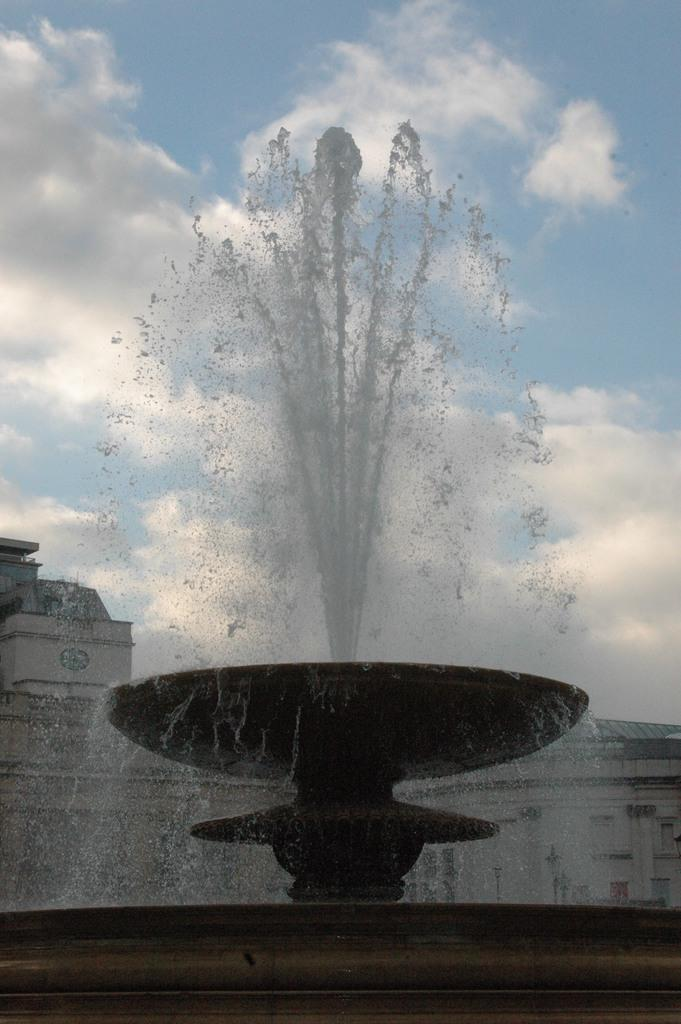What is the main subject of the image? There is a water fountain in the image. What can be seen in the background of the image? There are buildings and the sky visible in the background of the image. How many bulbs are illuminating the hall in the image? There is no hall or bulbs present in the image; it features a water fountain and buildings in the background. What type of scale is used to weigh the objects in the image? There is no scale or objects being weighed present in the image. 